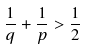Convert formula to latex. <formula><loc_0><loc_0><loc_500><loc_500>\frac { 1 } { q } + \frac { 1 } { p } > \frac { 1 } { 2 }</formula> 